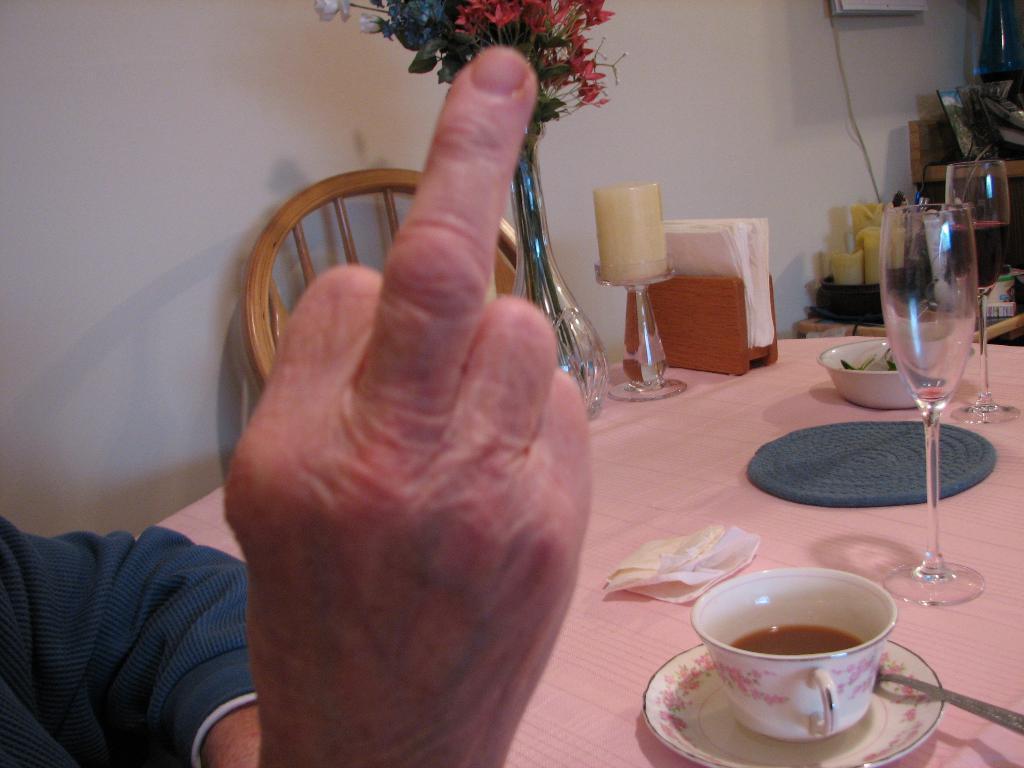Please provide a concise description of this image. In this image I can see a hand of a person. here on this table I can see few cups, a plate and two glasses. I can also see a chair and a candle, few napkins, few flowers and a spoon. 